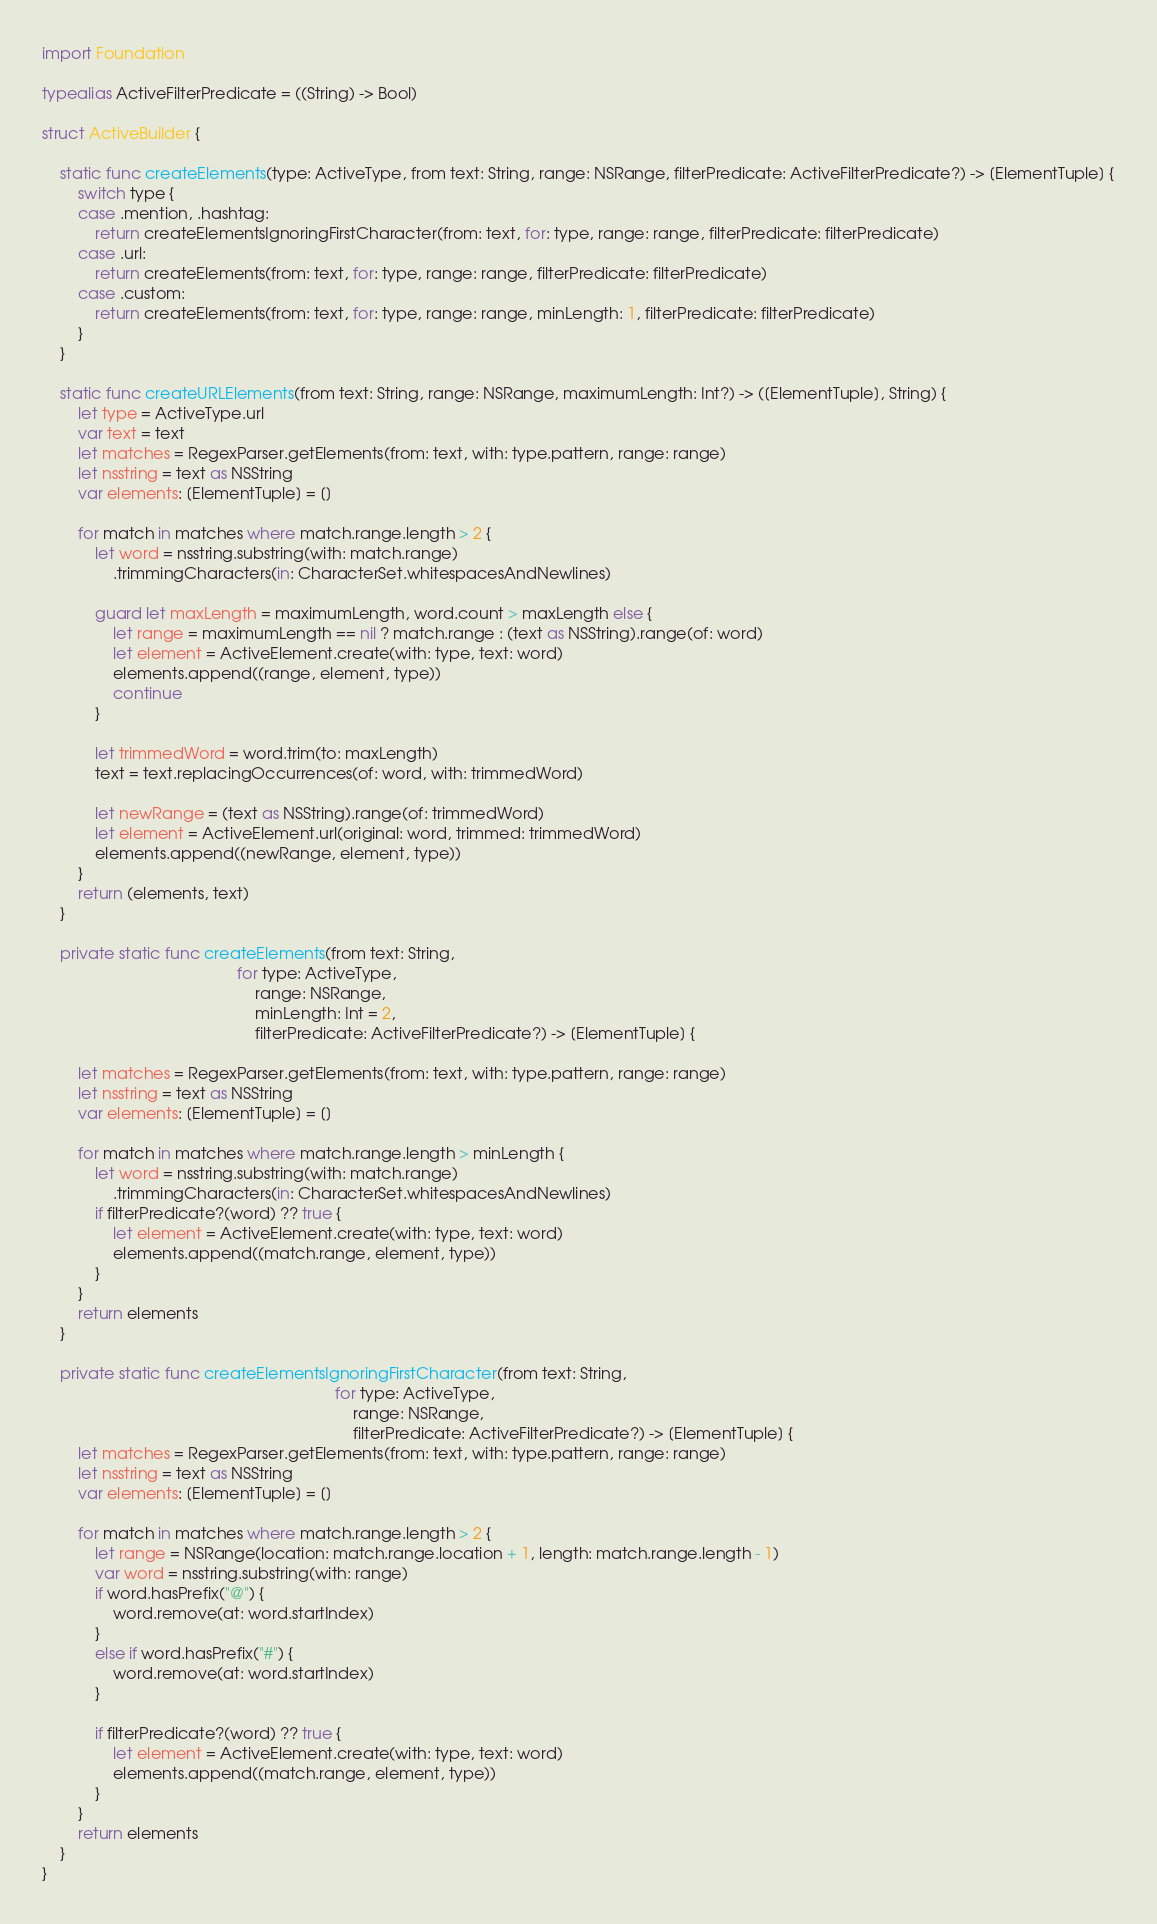<code> <loc_0><loc_0><loc_500><loc_500><_Swift_>import Foundation

typealias ActiveFilterPredicate = ((String) -> Bool)

struct ActiveBuilder {

    static func createElements(type: ActiveType, from text: String, range: NSRange, filterPredicate: ActiveFilterPredicate?) -> [ElementTuple] {
        switch type {
        case .mention, .hashtag:
            return createElementsIgnoringFirstCharacter(from: text, for: type, range: range, filterPredicate: filterPredicate)
        case .url:
            return createElements(from: text, for: type, range: range, filterPredicate: filterPredicate)
        case .custom:
            return createElements(from: text, for: type, range: range, minLength: 1, filterPredicate: filterPredicate)
        }
    }

    static func createURLElements(from text: String, range: NSRange, maximumLength: Int?) -> ([ElementTuple], String) {
        let type = ActiveType.url
        var text = text
        let matches = RegexParser.getElements(from: text, with: type.pattern, range: range)
        let nsstring = text as NSString
        var elements: [ElementTuple] = []

        for match in matches where match.range.length > 2 {
            let word = nsstring.substring(with: match.range)
                .trimmingCharacters(in: CharacterSet.whitespacesAndNewlines)

            guard let maxLength = maximumLength, word.count > maxLength else {
                let range = maximumLength == nil ? match.range : (text as NSString).range(of: word)
                let element = ActiveElement.create(with: type, text: word)
                elements.append((range, element, type))
                continue
            }

            let trimmedWord = word.trim(to: maxLength)
            text = text.replacingOccurrences(of: word, with: trimmedWord)

            let newRange = (text as NSString).range(of: trimmedWord)
            let element = ActiveElement.url(original: word, trimmed: trimmedWord)
            elements.append((newRange, element, type))
        }
        return (elements, text)
    }

    private static func createElements(from text: String,
                                            for type: ActiveType,
                                                range: NSRange,
                                                minLength: Int = 2,
                                                filterPredicate: ActiveFilterPredicate?) -> [ElementTuple] {

        let matches = RegexParser.getElements(from: text, with: type.pattern, range: range)
        let nsstring = text as NSString
        var elements: [ElementTuple] = []

        for match in matches where match.range.length > minLength {
            let word = nsstring.substring(with: match.range)
                .trimmingCharacters(in: CharacterSet.whitespacesAndNewlines)
            if filterPredicate?(word) ?? true {
                let element = ActiveElement.create(with: type, text: word)
                elements.append((match.range, element, type))
            }
        }
        return elements
    }

    private static func createElementsIgnoringFirstCharacter(from text: String,
                                                                  for type: ActiveType,
                                                                      range: NSRange,
                                                                      filterPredicate: ActiveFilterPredicate?) -> [ElementTuple] {
        let matches = RegexParser.getElements(from: text, with: type.pattern, range: range)
        let nsstring = text as NSString
        var elements: [ElementTuple] = []

        for match in matches where match.range.length > 2 {
            let range = NSRange(location: match.range.location + 1, length: match.range.length - 1)
            var word = nsstring.substring(with: range)
            if word.hasPrefix("@") {
                word.remove(at: word.startIndex)
            }
            else if word.hasPrefix("#") {
                word.remove(at: word.startIndex)
            }

            if filterPredicate?(word) ?? true {
                let element = ActiveElement.create(with: type, text: word)
                elements.append((match.range, element, type))
            }
        }
        return elements
    }
}
</code> 